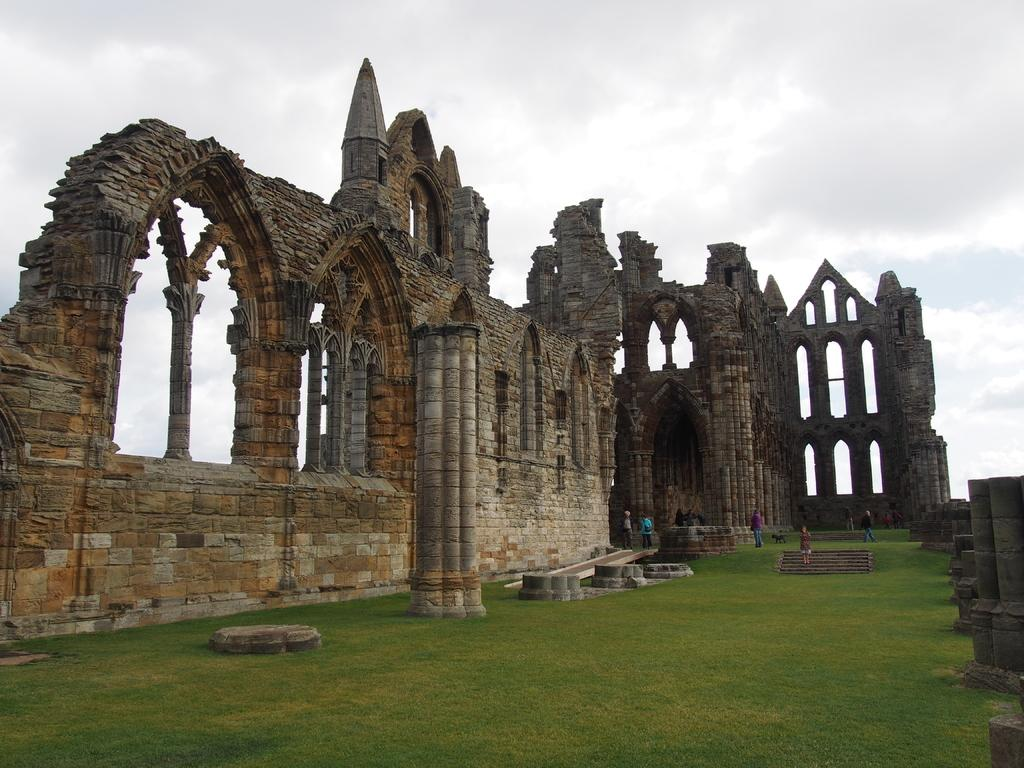What type of ground is visible in the image? There is a greenery ground in the image. Can you describe the people in the image? There are people standing in the image. What historical landmark is visible in the image? Whitby Abbey is visible beside the people. How would you describe the weather in the image? The sky is cloudy in the image. What type of peace symbol can be seen on the ground in the image? There is no peace symbol present on the ground in the image. What kind of bag is being carried by the people in the image? The image does not show any bags being carried by the people. 